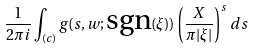<formula> <loc_0><loc_0><loc_500><loc_500>\frac { 1 } { 2 \pi i } \int _ { ( c ) } g ( s , w ; \text {sgn} ( \xi ) ) \left ( \frac { X } { \pi | \xi | } \right ) ^ { s } \, d s</formula> 